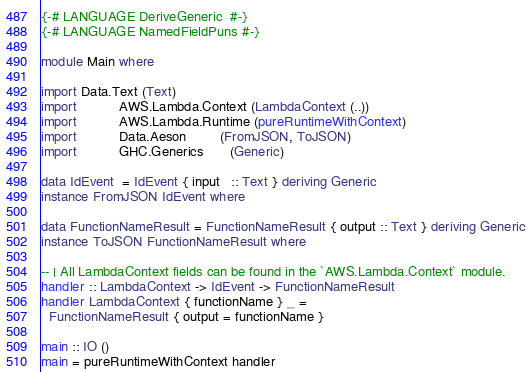<code> <loc_0><loc_0><loc_500><loc_500><_Haskell_>{-# LANGUAGE DeriveGeneric  #-}
{-# LANGUAGE NamedFieldPuns #-}

module Main where

import Data.Text (Text)
import           AWS.Lambda.Context (LambdaContext (..))
import           AWS.Lambda.Runtime (pureRuntimeWithContext)
import           Data.Aeson         (FromJSON, ToJSON)
import           GHC.Generics       (Generic)

data IdEvent  = IdEvent { input   :: Text } deriving Generic
instance FromJSON IdEvent where

data FunctionNameResult = FunctionNameResult { output :: Text } deriving Generic
instance ToJSON FunctionNameResult where

-- | All LambdaContext fields can be found in the `AWS.Lambda.Context` module.
handler :: LambdaContext -> IdEvent -> FunctionNameResult
handler LambdaContext { functionName } _ =
  FunctionNameResult { output = functionName }

main :: IO ()
main = pureRuntimeWithContext handler
</code> 